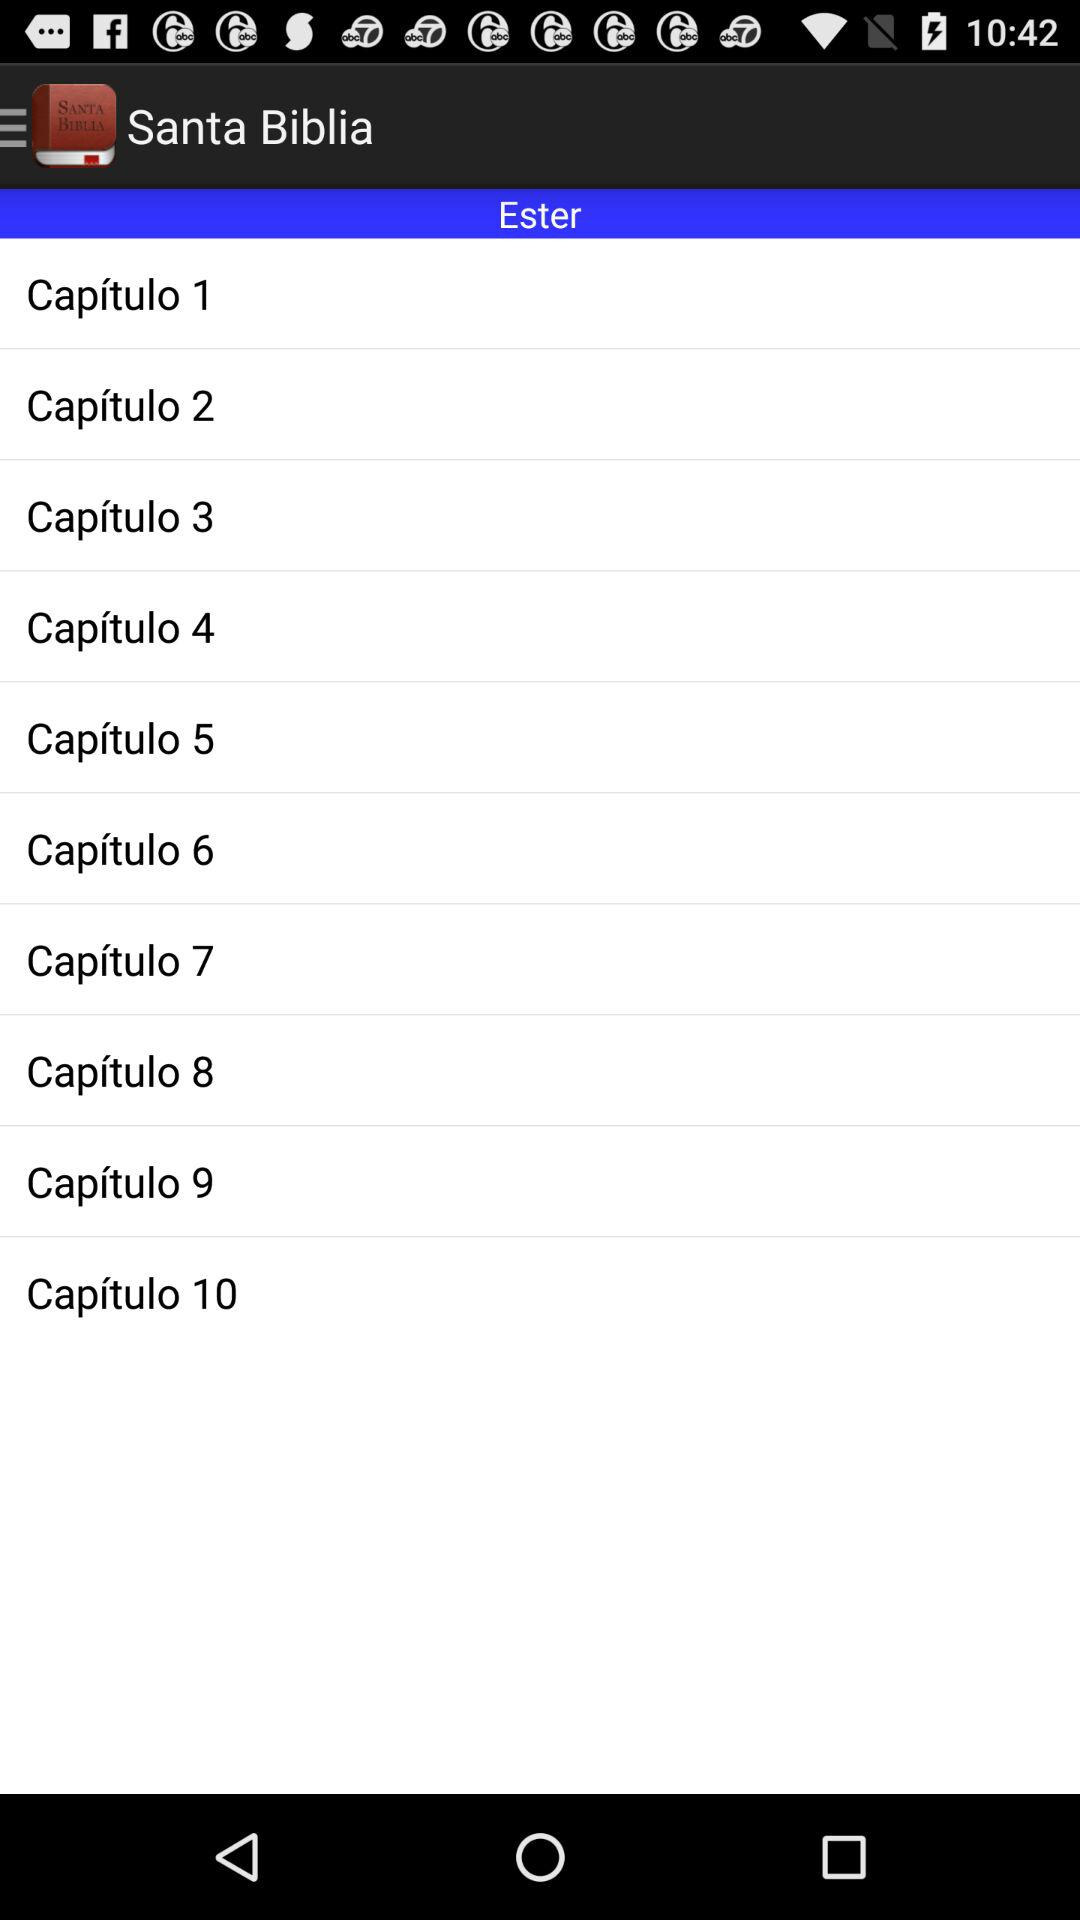How many chapters are there between chapter 1 and chapter 10?
Answer the question using a single word or phrase. 9 